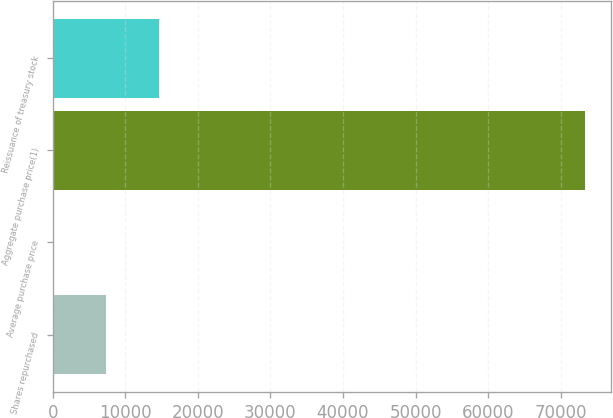Convert chart to OTSL. <chart><loc_0><loc_0><loc_500><loc_500><bar_chart><fcel>Shares repurchased<fcel>Average purchase price<fcel>Aggregate purchase price(1)<fcel>Reissuance of treasury stock<nl><fcel>7360.18<fcel>29.64<fcel>73335<fcel>14690.7<nl></chart> 